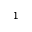Convert formula to latex. <formula><loc_0><loc_0><loc_500><loc_500>^ { 1 }</formula> 